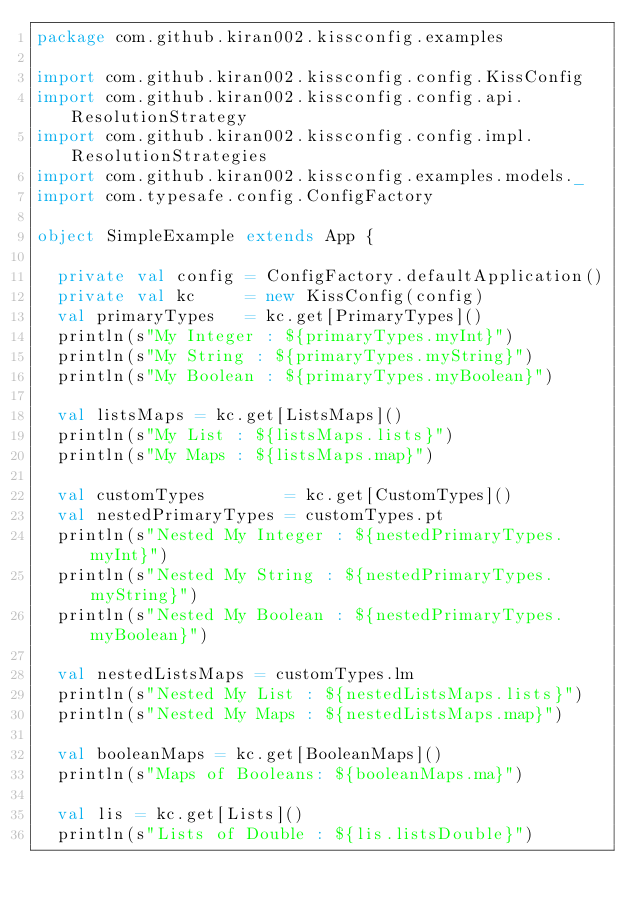<code> <loc_0><loc_0><loc_500><loc_500><_Scala_>package com.github.kiran002.kissconfig.examples

import com.github.kiran002.kissconfig.config.KissConfig
import com.github.kiran002.kissconfig.config.api.ResolutionStrategy
import com.github.kiran002.kissconfig.config.impl.ResolutionStrategies
import com.github.kiran002.kissconfig.examples.models._
import com.typesafe.config.ConfigFactory

object SimpleExample extends App {

  private val config = ConfigFactory.defaultApplication()
  private val kc     = new KissConfig(config)
  val primaryTypes   = kc.get[PrimaryTypes]()
  println(s"My Integer : ${primaryTypes.myInt}")
  println(s"My String : ${primaryTypes.myString}")
  println(s"My Boolean : ${primaryTypes.myBoolean}")

  val listsMaps = kc.get[ListsMaps]()
  println(s"My List : ${listsMaps.lists}")
  println(s"My Maps : ${listsMaps.map}")

  val customTypes        = kc.get[CustomTypes]()
  val nestedPrimaryTypes = customTypes.pt
  println(s"Nested My Integer : ${nestedPrimaryTypes.myInt}")
  println(s"Nested My String : ${nestedPrimaryTypes.myString}")
  println(s"Nested My Boolean : ${nestedPrimaryTypes.myBoolean}")

  val nestedListsMaps = customTypes.lm
  println(s"Nested My List : ${nestedListsMaps.lists}")
  println(s"Nested My Maps : ${nestedListsMaps.map}")

  val booleanMaps = kc.get[BooleanMaps]()
  println(s"Maps of Booleans: ${booleanMaps.ma}")

  val lis = kc.get[Lists]()
  println(s"Lists of Double : ${lis.listsDouble}")</code> 